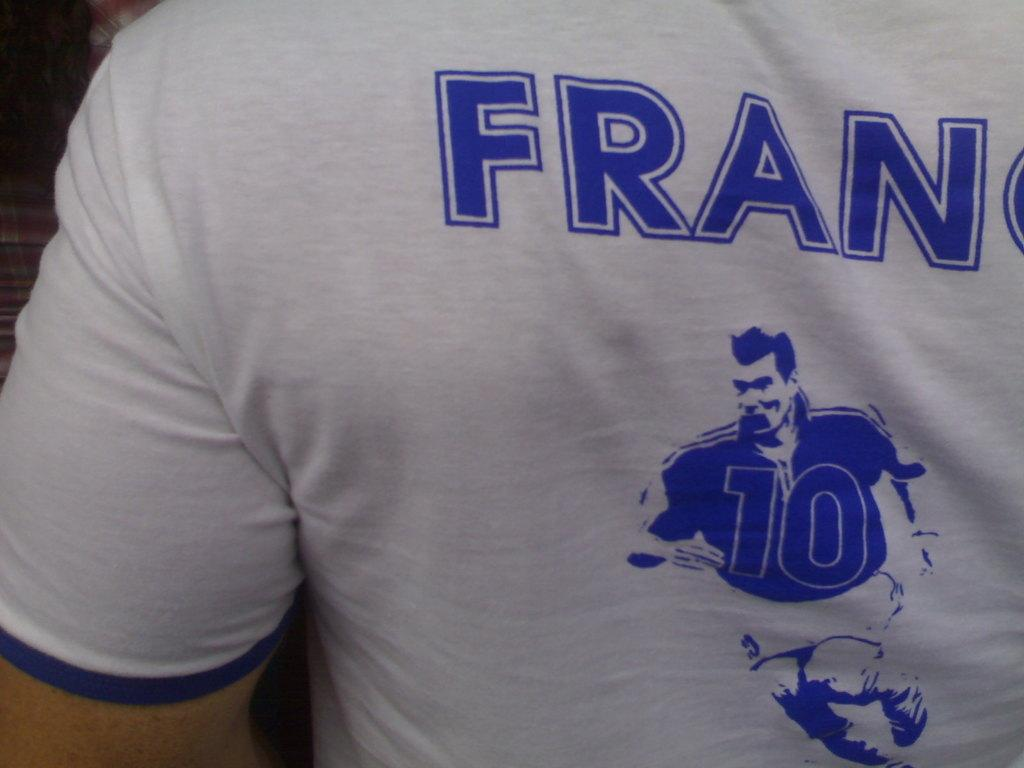<image>
Provide a brief description of the given image. A person wears a white and blue shirt that says FRAN 